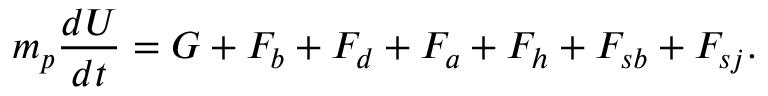Convert formula to latex. <formula><loc_0><loc_0><loc_500><loc_500>m _ { p } \frac { d U } { d t } = G + F _ { b } + F _ { d } + F _ { a } + F _ { h } + F _ { s b } + F _ { s j } .</formula> 